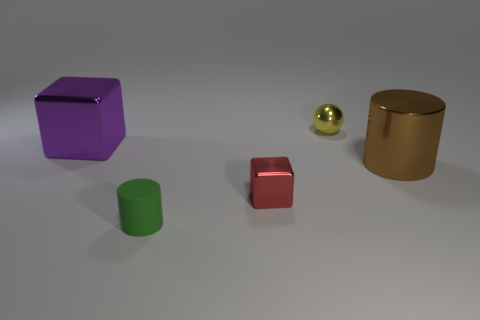Add 1 rubber blocks. How many objects exist? 6 Subtract all spheres. How many objects are left? 4 Subtract all tiny gray shiny balls. Subtract all small green matte things. How many objects are left? 4 Add 4 large purple blocks. How many large purple blocks are left? 5 Add 1 large purple things. How many large purple things exist? 2 Subtract 0 blue blocks. How many objects are left? 5 